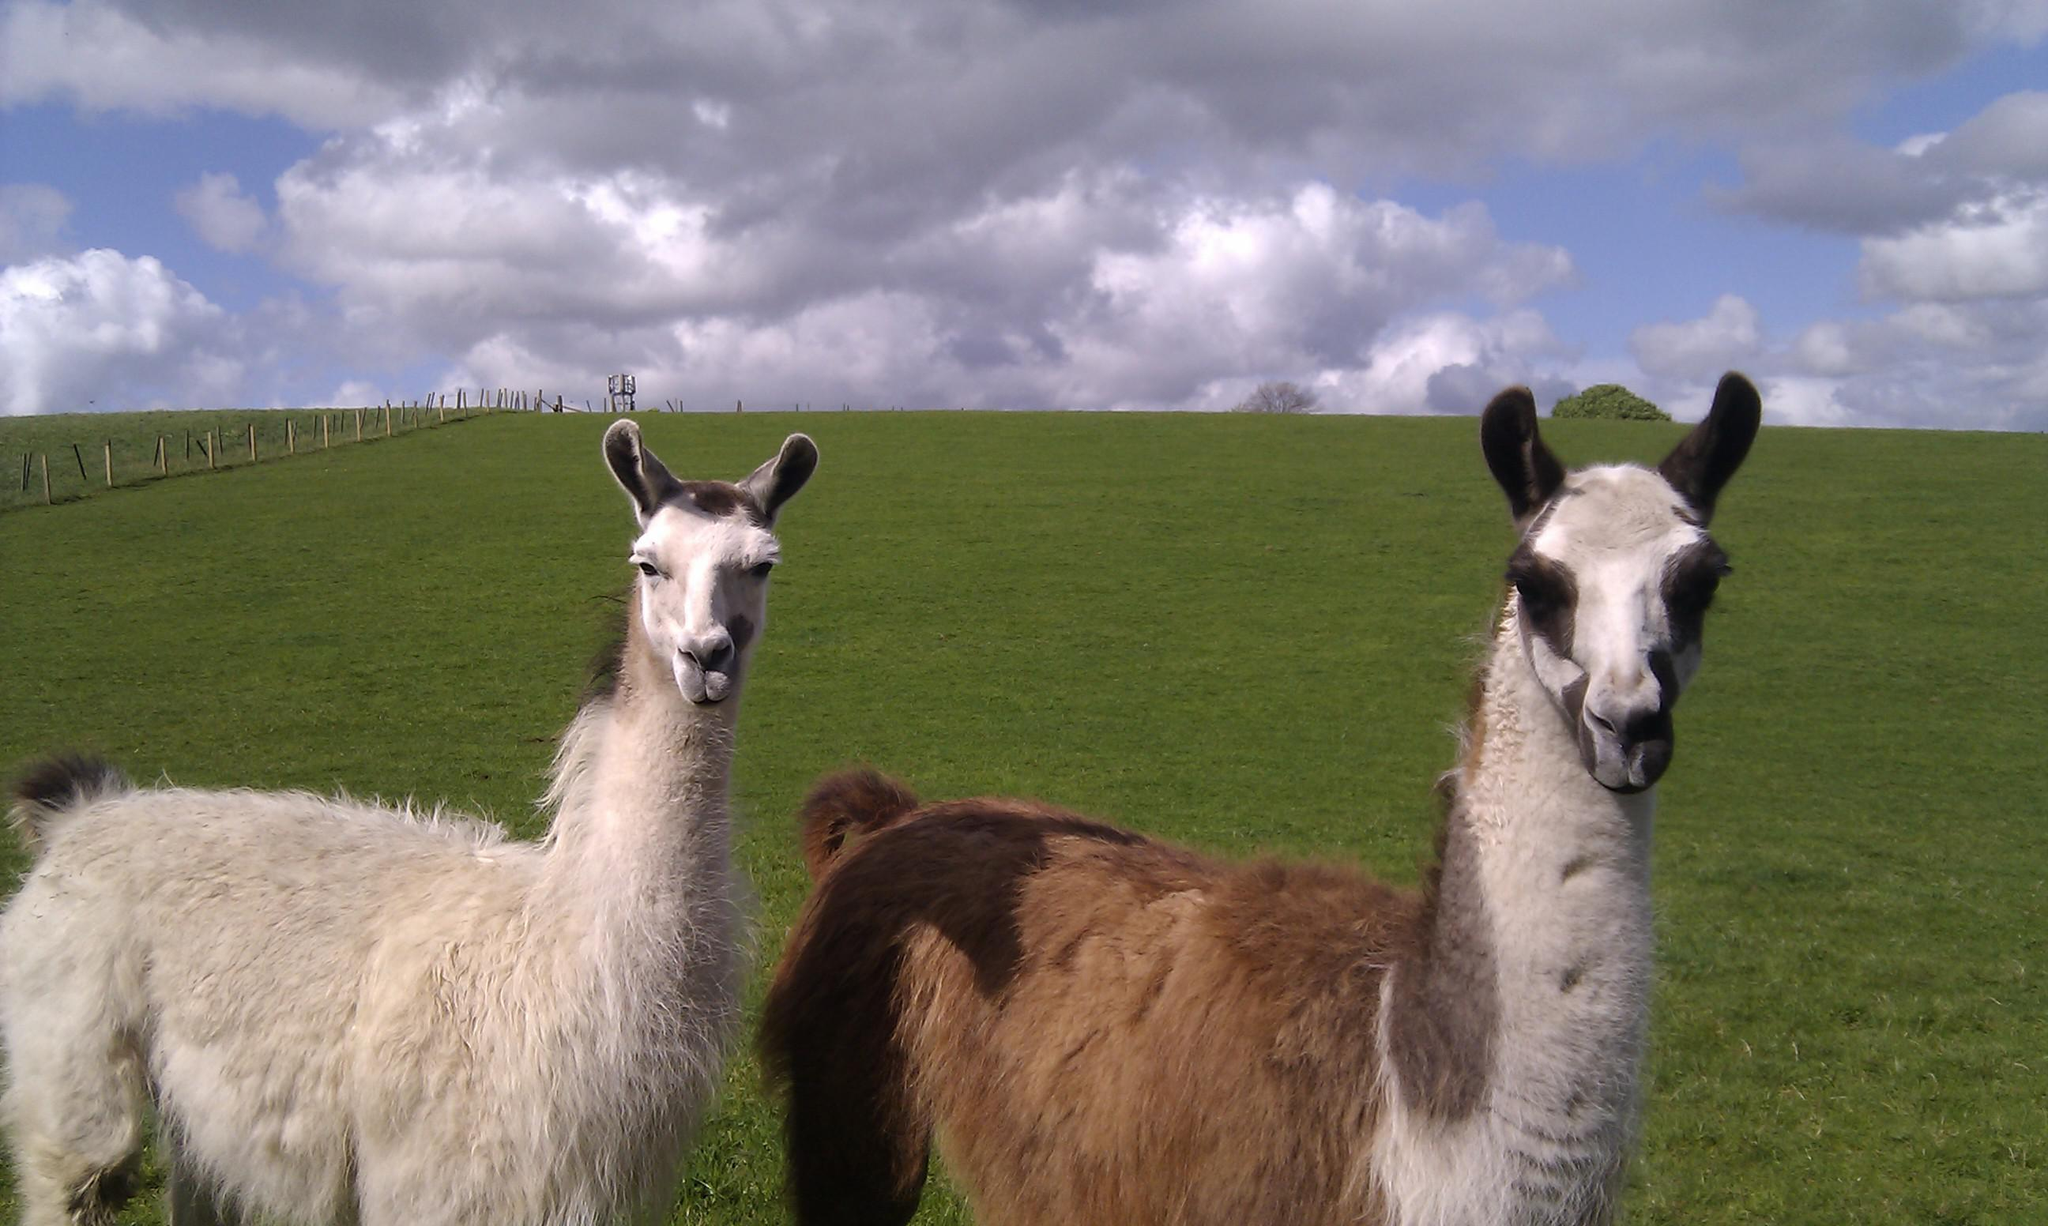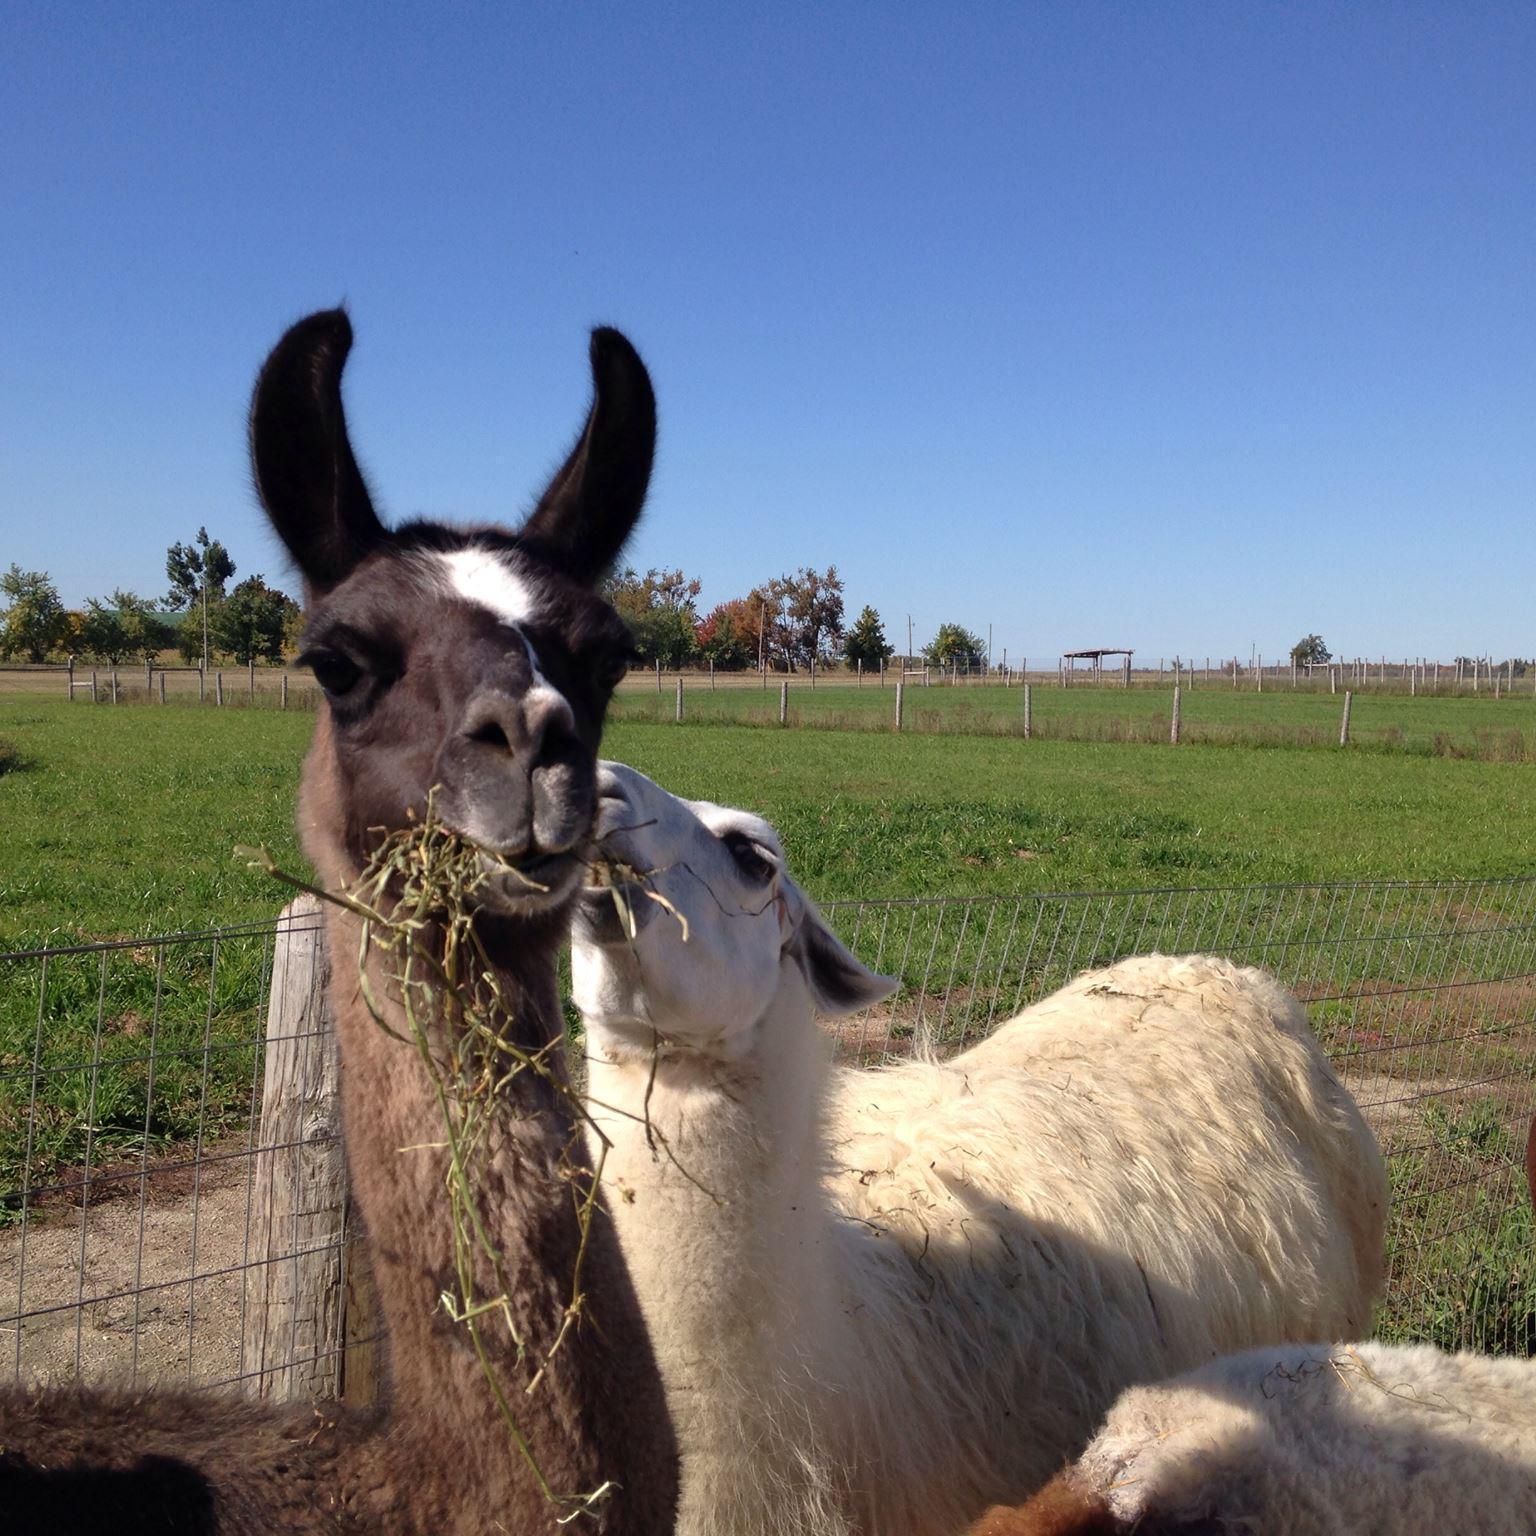The first image is the image on the left, the second image is the image on the right. Evaluate the accuracy of this statement regarding the images: "There are llamas next to a wire fence.". Is it true? Answer yes or no. Yes. The first image is the image on the left, the second image is the image on the right. Examine the images to the left and right. Is the description "The llamas in the image on the right are standing with their sides touching." accurate? Answer yes or no. Yes. 